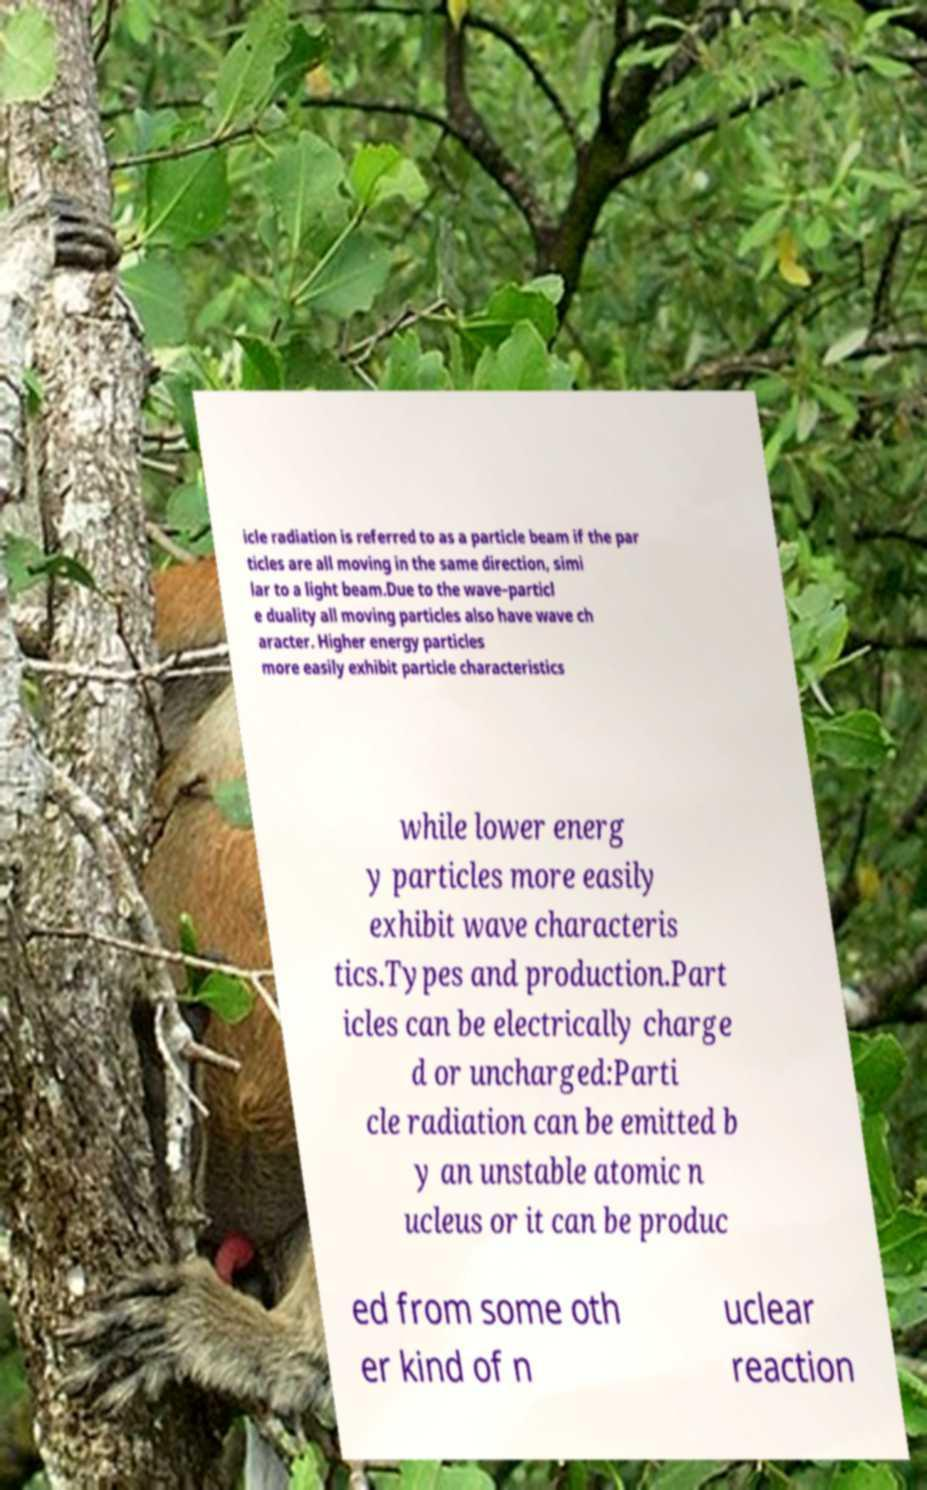I need the written content from this picture converted into text. Can you do that? icle radiation is referred to as a particle beam if the par ticles are all moving in the same direction, simi lar to a light beam.Due to the wave–particl e duality all moving particles also have wave ch aracter. Higher energy particles more easily exhibit particle characteristics while lower energ y particles more easily exhibit wave characteris tics.Types and production.Part icles can be electrically charge d or uncharged:Parti cle radiation can be emitted b y an unstable atomic n ucleus or it can be produc ed from some oth er kind of n uclear reaction 